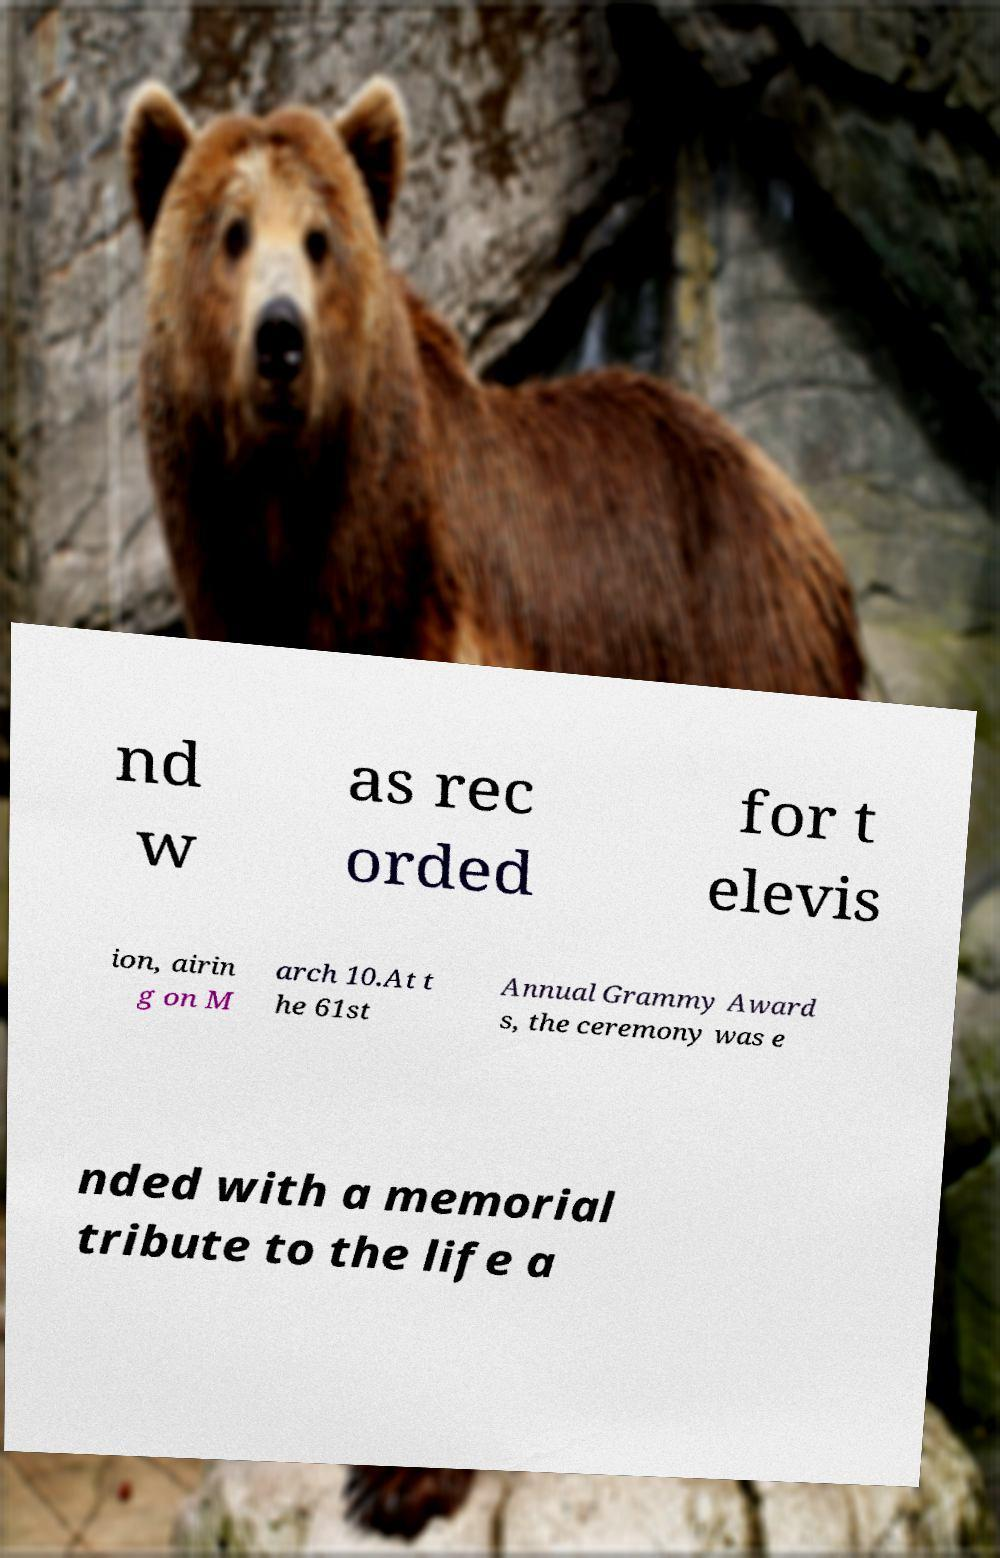I need the written content from this picture converted into text. Can you do that? nd w as rec orded for t elevis ion, airin g on M arch 10.At t he 61st Annual Grammy Award s, the ceremony was e nded with a memorial tribute to the life a 